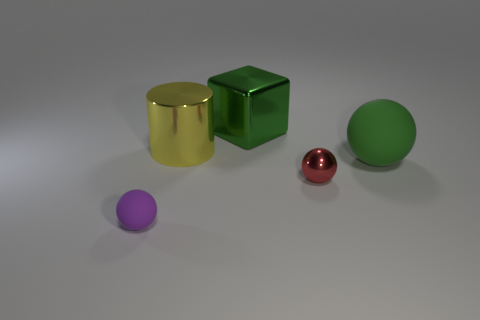Add 4 large cyan cylinders. How many objects exist? 9 Subtract all red spheres. How many spheres are left? 2 Subtract all tiny red spheres. How many spheres are left? 2 Subtract 0 cyan blocks. How many objects are left? 5 Subtract all spheres. How many objects are left? 2 Subtract 1 balls. How many balls are left? 2 Subtract all gray cubes. Subtract all brown balls. How many cubes are left? 1 Subtract all red cubes. How many gray spheres are left? 0 Subtract all gray metallic cubes. Subtract all red metallic objects. How many objects are left? 4 Add 1 big metal cubes. How many big metal cubes are left? 2 